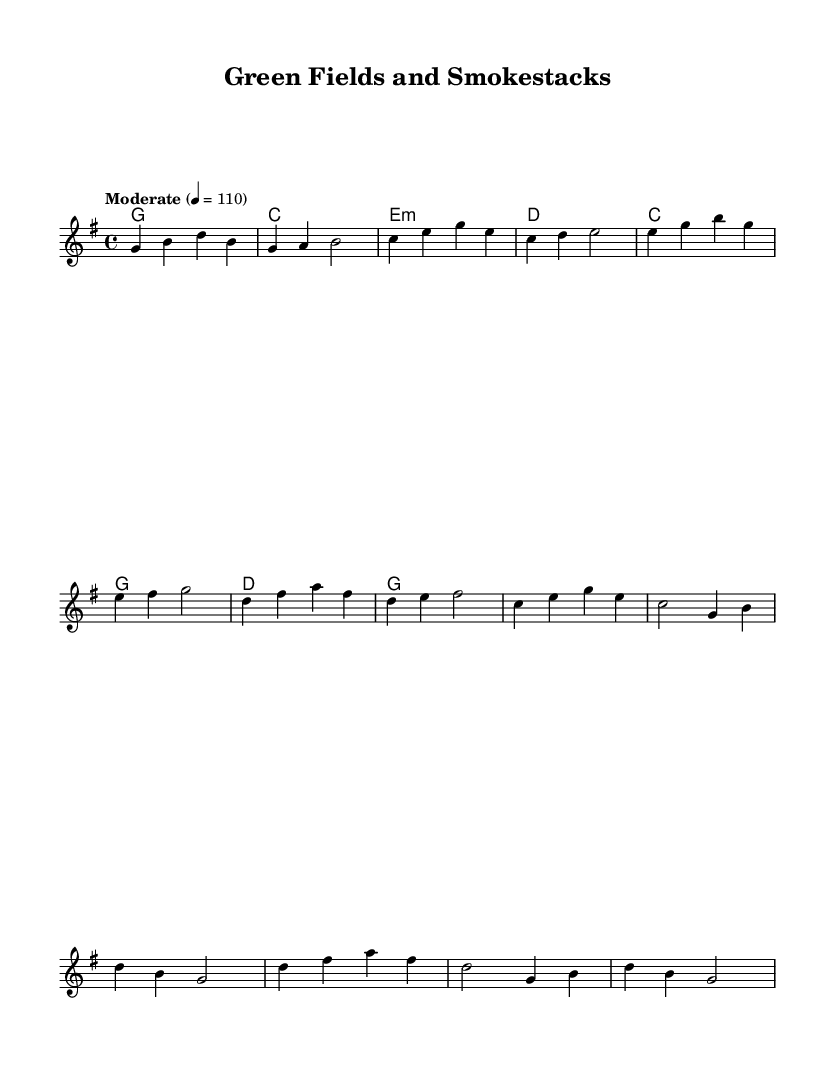What is the key signature of this music? The key signature is G major, which has one sharp (F#). This can be identified from the global section where the key is specified as "g \major".
Answer: G major What is the time signature of the piece? The time signature is 4/4, as indicated in the global section of the code where it states "\time 4/4". This means there are four beats in each measure.
Answer: 4/4 What tempo marking is given for the music? The tempo marking is "Moderate" at 110 beats per minute. This is specified in the global section with the tempo instruction.
Answer: Moderate 110 How many measures are in the verse? There are eight measures in the verse section. This can be counted by looking at the melody section's structure before transitioning to the chorus.
Answer: Eight What is the primary chord used in the chorus? The primary chord used in the chorus is C major, which appears first in the chord progression. This is indicated in the harmonies section.
Answer: C major What is the relationship between the verse and chorus in this piece? The verse and chorus both use similar melodic motifs but employ different chord progressions, showcasing a contrast between narrative lyricism and musical resolution. The verse's last chord transitions smoothly into the chorus.
Answer: Contrast What lyrical theme is suggested by the title "Green Fields and Smokestacks"? The lyrical theme suggests a conflict or balance between natural landscapes ("Green Fields") and industrial development ("Smokestacks"), reflecting environmental concerns in the context of country rock music.
Answer: Conflict between nature and industry 